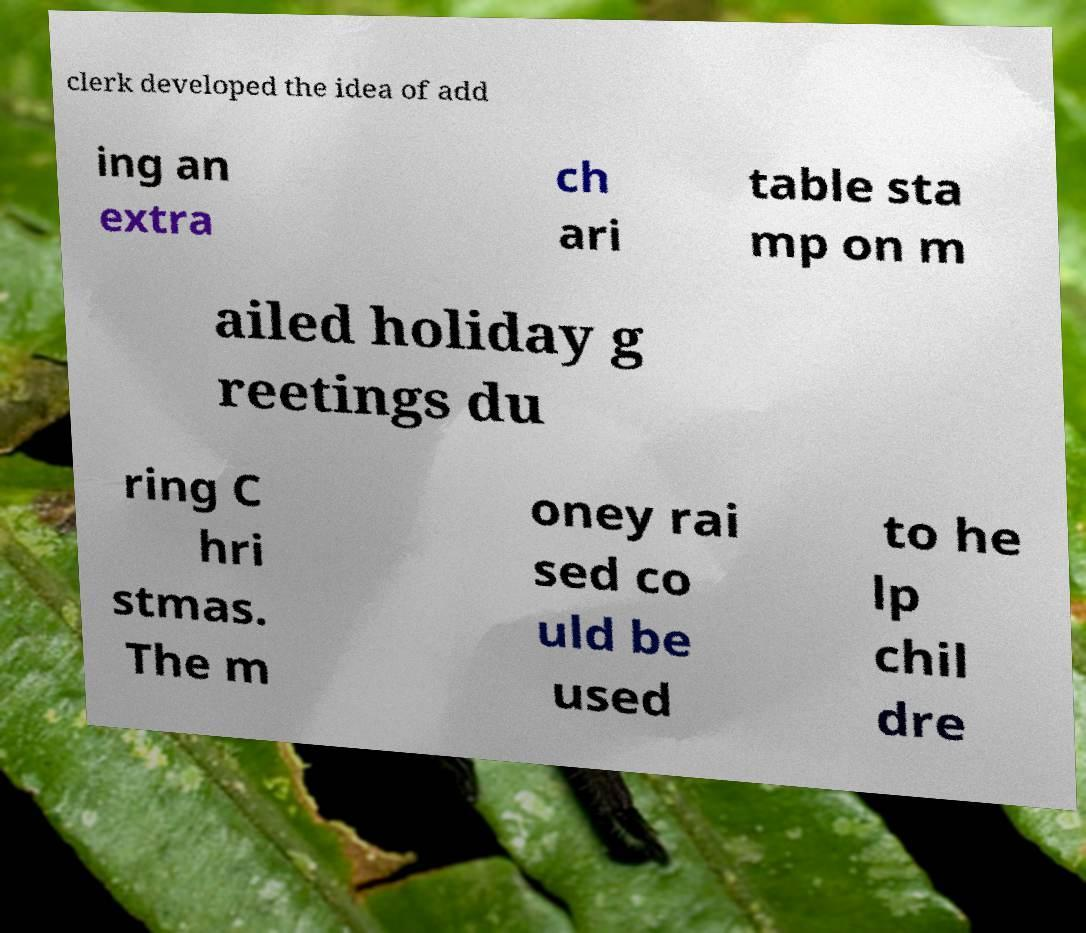Can you read and provide the text displayed in the image?This photo seems to have some interesting text. Can you extract and type it out for me? clerk developed the idea of add ing an extra ch ari table sta mp on m ailed holiday g reetings du ring C hri stmas. The m oney rai sed co uld be used to he lp chil dre 